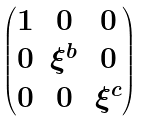Convert formula to latex. <formula><loc_0><loc_0><loc_500><loc_500>\begin{pmatrix} 1 & 0 & 0 \\ 0 & \xi ^ { b } & 0 \\ 0 & 0 & \xi ^ { c } \end{pmatrix}</formula> 